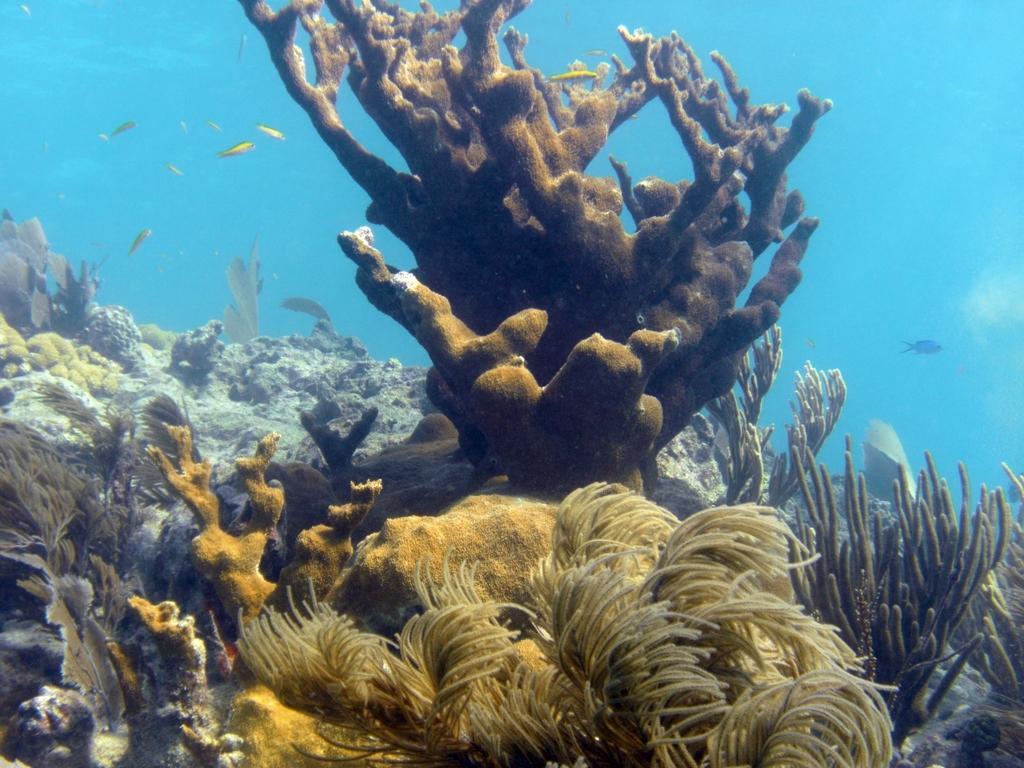Please provide a concise description of this image. In this image there are fishes and water plants in the water. 